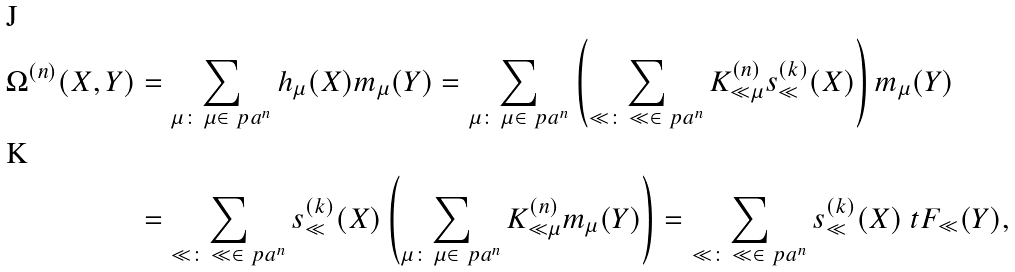Convert formula to latex. <formula><loc_0><loc_0><loc_500><loc_500>\Omega ^ { ( n ) } ( X , Y ) & = \sum _ { \mu \colon \, \mu \in \ p a ^ { n } } h _ { \mu } ( X ) m _ { \mu } ( Y ) = \sum _ { \mu \colon \, \mu \in \ p a ^ { n } } \left ( \sum _ { \ll \colon \, \ll \in \ p a ^ { n } } K ^ { ( n ) } _ { \ll \mu } s ^ { ( k ) } _ { \ll } ( X ) \right ) m _ { \mu } ( Y ) \\ & = \sum _ { \ll \colon \, \ll \in \ p a ^ { n } } s ^ { ( k ) } _ { \ll } ( X ) \left ( \sum _ { \mu \colon \, \mu \in \ p a ^ { n } } K ^ { ( n ) } _ { \ll \mu } m _ { \mu } ( Y ) \right ) = \sum _ { \ll \colon \, \ll \in \ p a ^ { n } } s ^ { ( k ) } _ { \ll } ( X ) \ t F _ { \ll } ( Y ) ,</formula> 